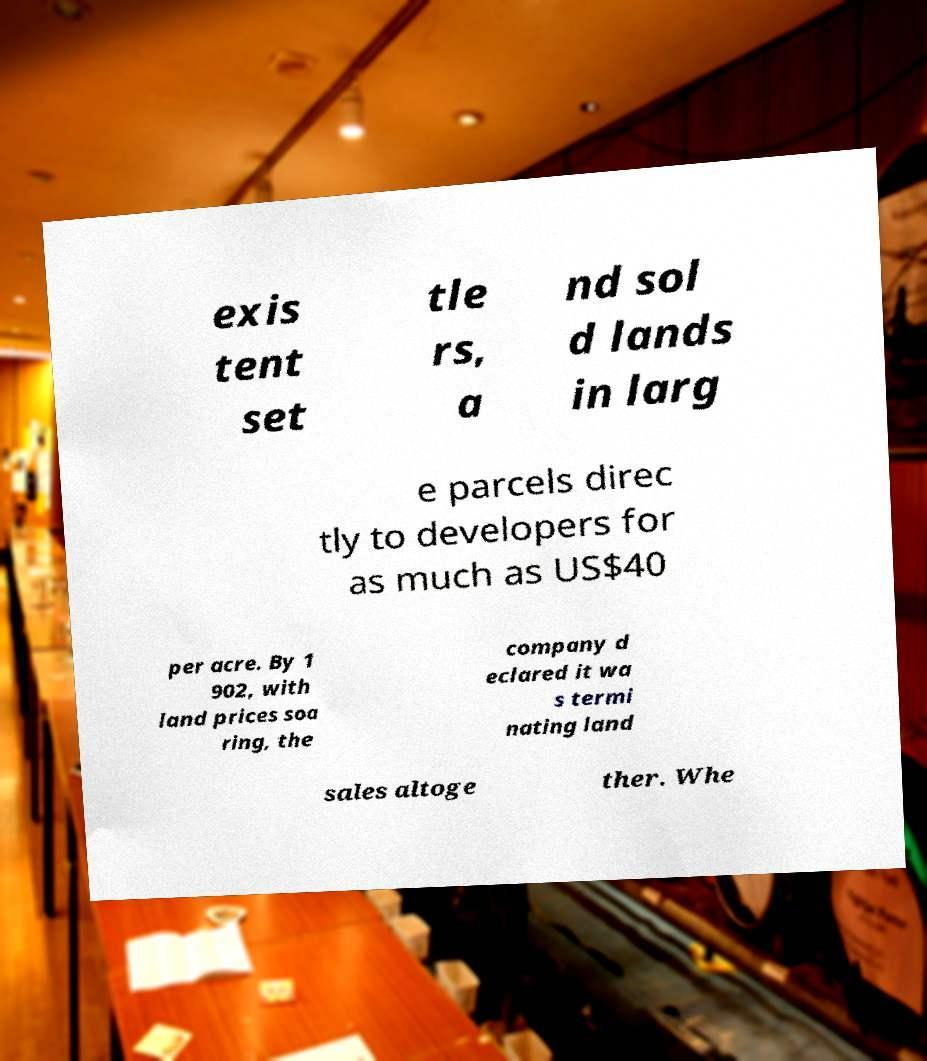Can you accurately transcribe the text from the provided image for me? exis tent set tle rs, a nd sol d lands in larg e parcels direc tly to developers for as much as US$40 per acre. By 1 902, with land prices soa ring, the company d eclared it wa s termi nating land sales altoge ther. Whe 